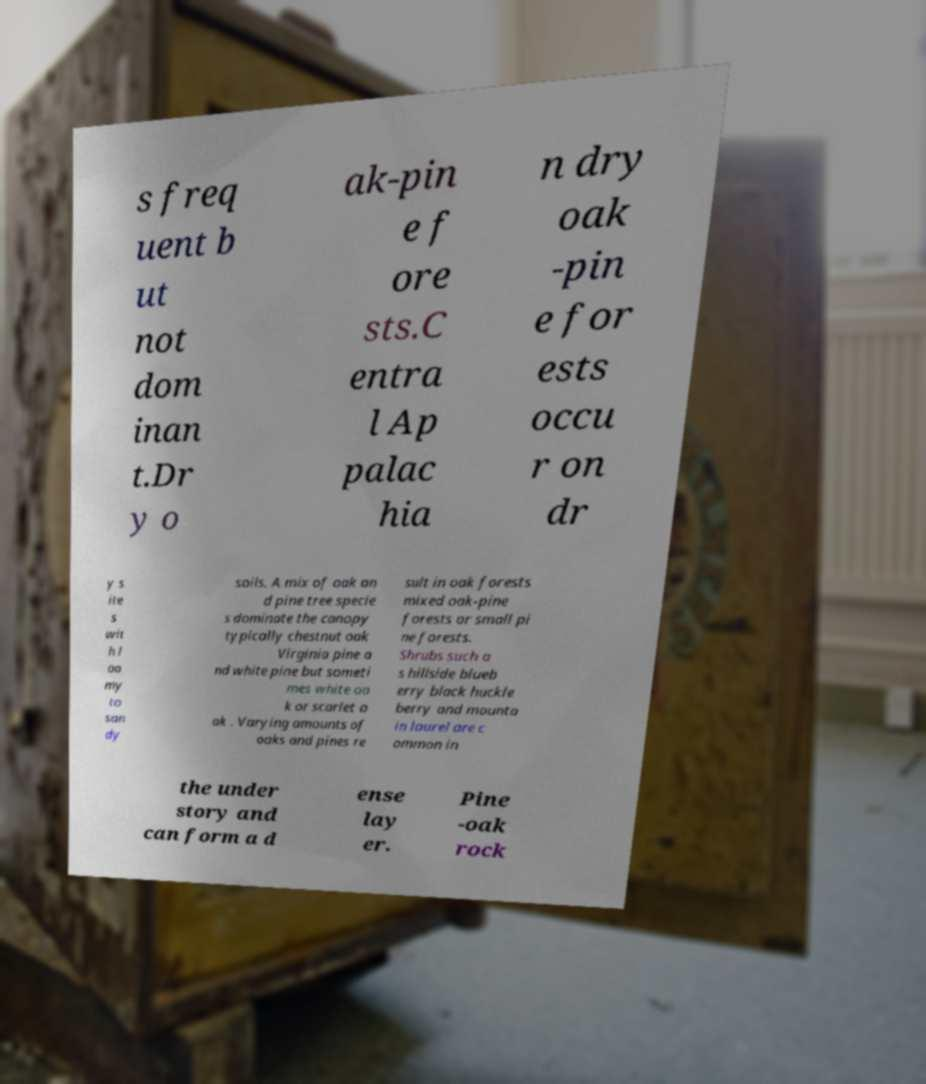I need the written content from this picture converted into text. Can you do that? s freq uent b ut not dom inan t.Dr y o ak-pin e f ore sts.C entra l Ap palac hia n dry oak -pin e for ests occu r on dr y s ite s wit h l oa my to san dy soils. A mix of oak an d pine tree specie s dominate the canopy typically chestnut oak Virginia pine a nd white pine but someti mes white oa k or scarlet o ak . Varying amounts of oaks and pines re sult in oak forests mixed oak-pine forests or small pi ne forests. Shrubs such a s hillside blueb erry black huckle berry and mounta in laurel are c ommon in the under story and can form a d ense lay er. Pine -oak rock 